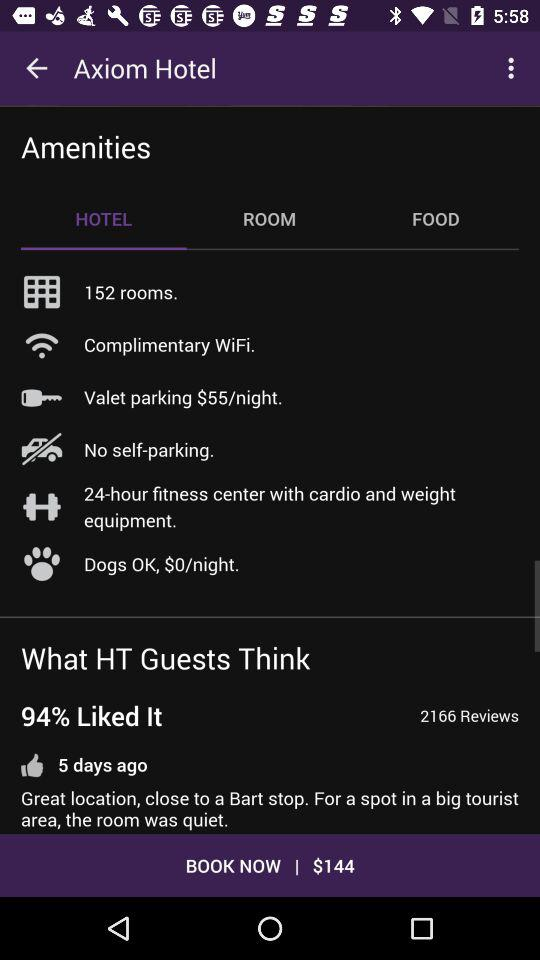Which tab is selected? The selected tab is "HOTEL". 